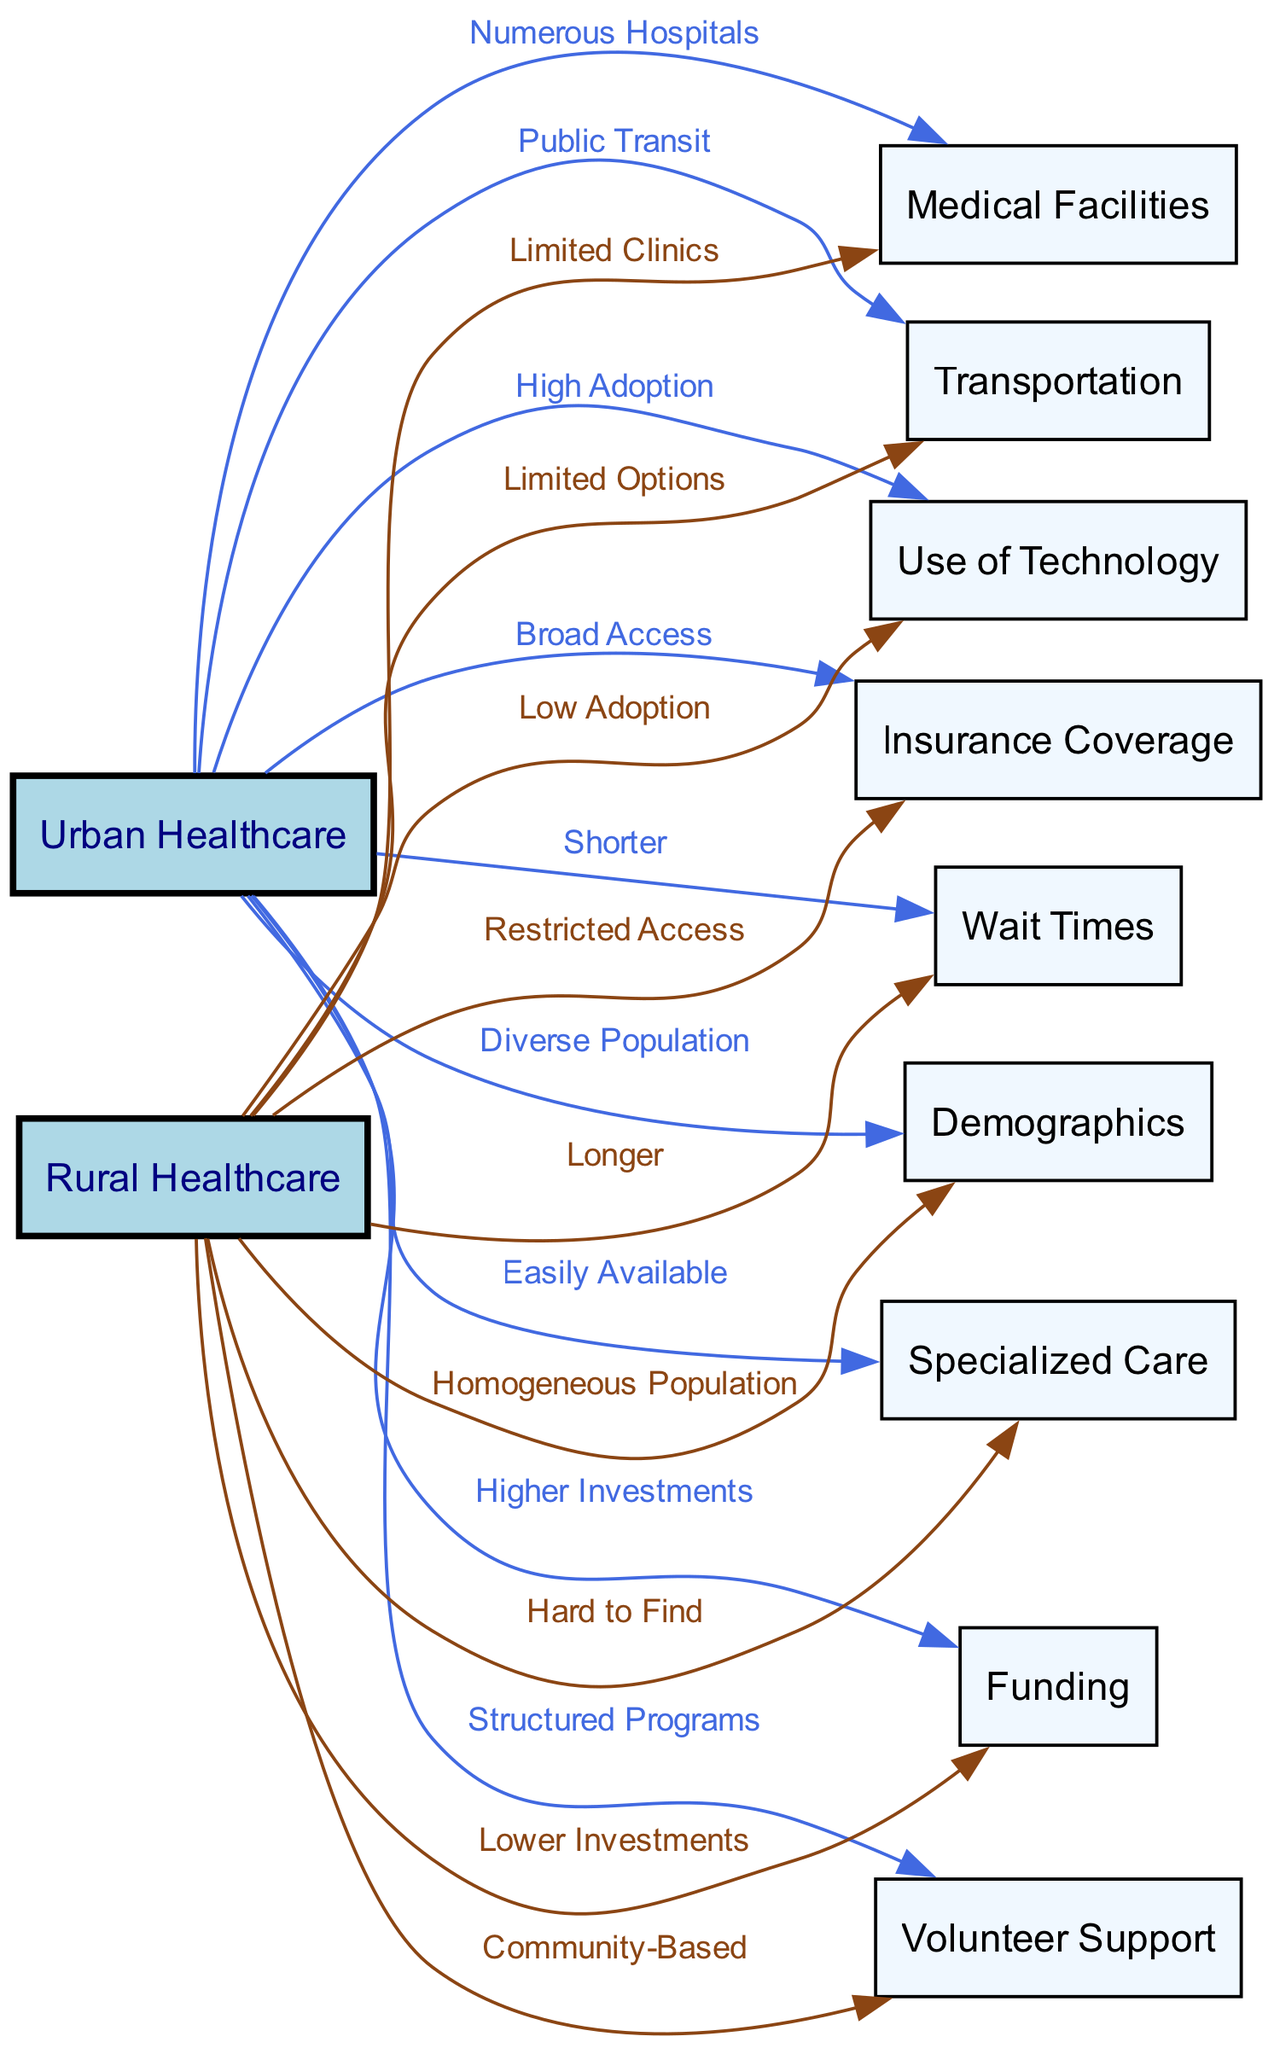What is the primary difference in the availability of medical facilities in urban healthcare compared to rural healthcare? The diagram indicates that urban healthcare has "Numerous Hospitals," while rural healthcare has "Limited Clinics." This shows a distinct difference in the number and types of medical facilities available to elderly residents in these settings.
Answer: Numerous Hospitals vs. Limited Clinics Which type of transportation is associated with urban healthcare? According to the diagram, urban healthcare is connected to "Public Transit," indicating that there are available transportation services to assist elderly residents in accessing healthcare services.
Answer: Public Transit What does rural healthcare offer in terms of insurance coverage? The diagram states that rural healthcare is linked to "Restricted Access," which suggests that elderly residents in rural areas may face more challenges regarding insurance coverage when compared to those in urban areas.
Answer: Restricted Access Which support system is indicated to be more organized in urban healthcare? The diagram points out that urban healthcare is associated with "Structured Programs" under volunteer support, indicating a more formal approach to involving volunteers in healthcare initiatives for the elderly.
Answer: Structured Programs What is one major challenge regarding specialized care in rural healthcare? The diagram notes that specialized care in rural healthcare is "Hard to Find," which implies that elderly residents face significant difficulties in accessing this kind of care in rural settings compared to urban areas where it is easily available.
Answer: Hard to Find How do wait times for healthcare compare between urban and rural settings? The diagram shows that urban healthcare has "Shorter" wait times while rural healthcare has "Longer" wait times. This comparison suggests that elderly residents in urban areas might receive health services more promptly than those in rural areas.
Answer: Shorter vs. Longer Which demographic characteristic distinguishes urban healthcare from rural healthcare? The diagram claims that urban healthcare has a "Diverse Population," while rural healthcare is described as a "Homogeneous Population." This distinction highlights the differences in the demographics of elder residents accessing healthcare services.
Answer: Diverse Population vs. Homogeneous Population What technological capability is higher in urban healthcare compared to rural healthcare? The diagram indicates that urban healthcare has "High Adoption" of technology, whereas rural healthcare shows "Low Adoption." This suggests that elderly residents in urban settings might benefit from more advanced healthcare technologies than those in rural settings.
Answer: High Adoption vs. Low Adoption 